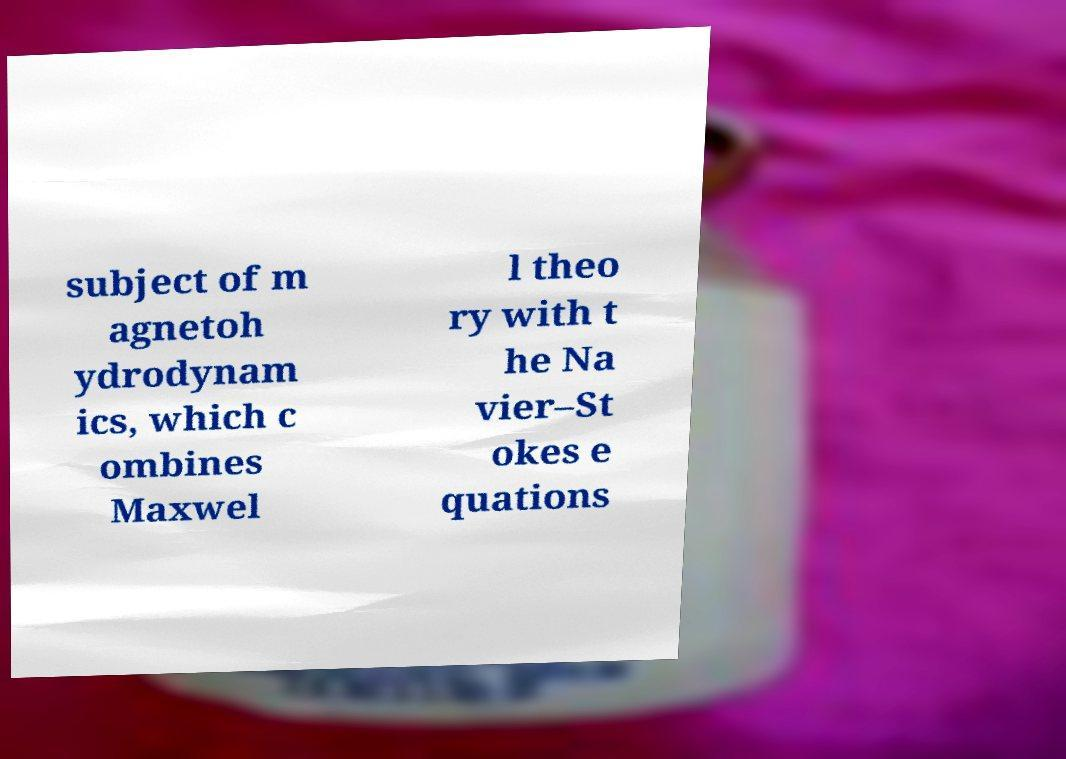Could you extract and type out the text from this image? subject of m agnetoh ydrodynam ics, which c ombines Maxwel l theo ry with t he Na vier–St okes e quations 